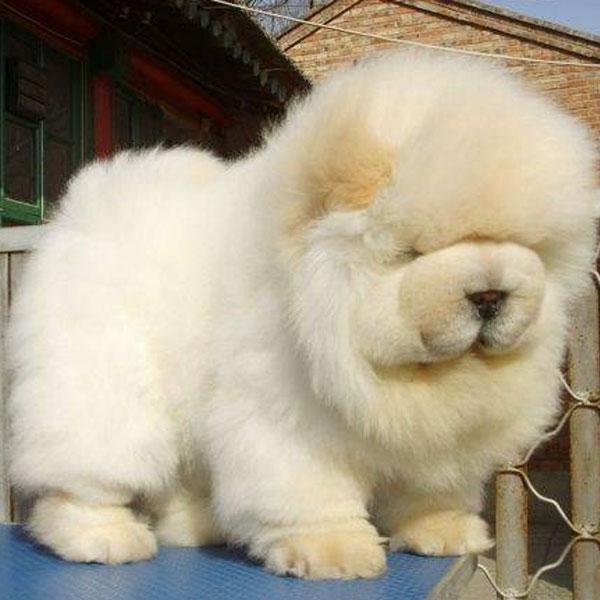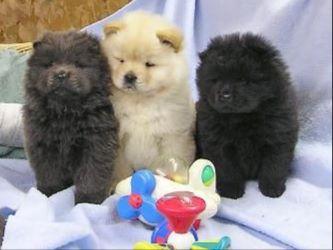The first image is the image on the left, the second image is the image on the right. Evaluate the accuracy of this statement regarding the images: "In one of the images there are three puppies sitting in a row.". Is it true? Answer yes or no. Yes. The first image is the image on the left, the second image is the image on the right. Given the left and right images, does the statement "Three puppies sit side by side on a white cloth in one image, while a single pup appears in the other image, all with their mouths closed." hold true? Answer yes or no. Yes. 